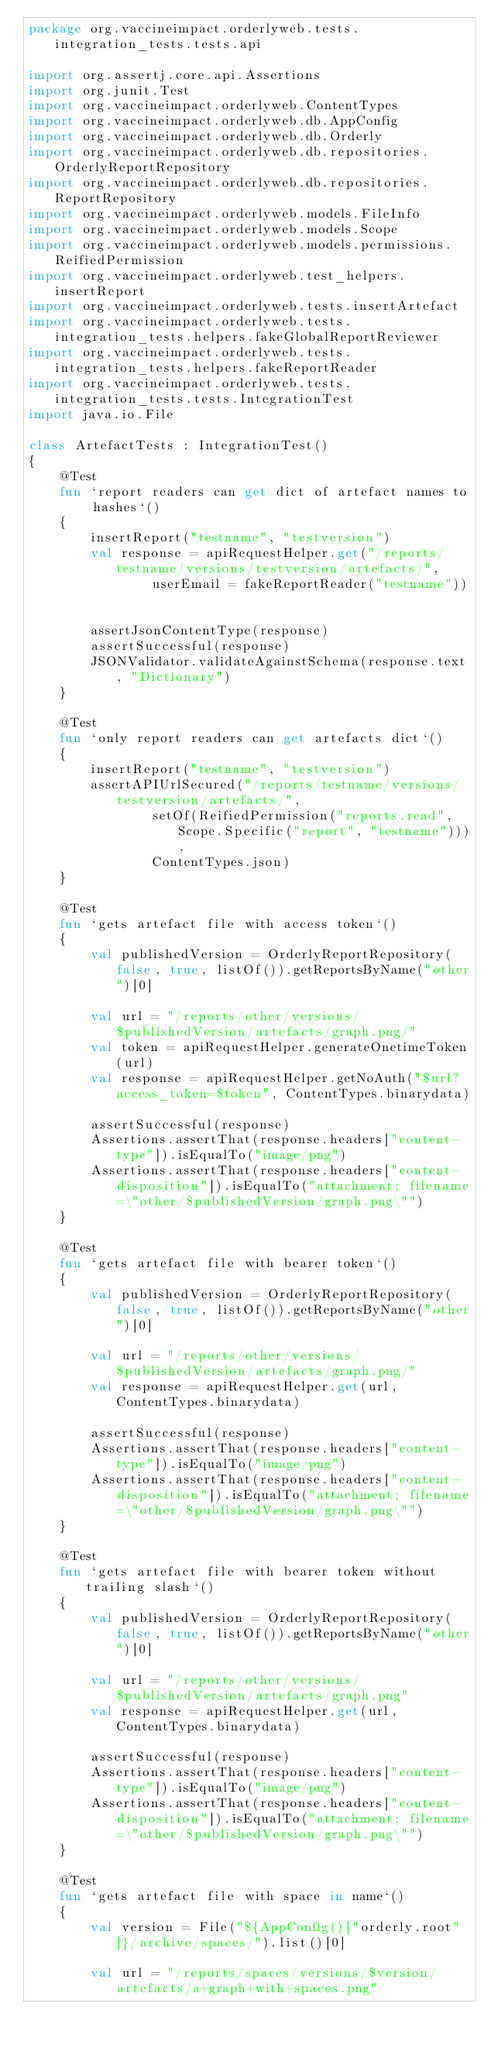<code> <loc_0><loc_0><loc_500><loc_500><_Kotlin_>package org.vaccineimpact.orderlyweb.tests.integration_tests.tests.api

import org.assertj.core.api.Assertions
import org.junit.Test
import org.vaccineimpact.orderlyweb.ContentTypes
import org.vaccineimpact.orderlyweb.db.AppConfig
import org.vaccineimpact.orderlyweb.db.Orderly
import org.vaccineimpact.orderlyweb.db.repositories.OrderlyReportRepository
import org.vaccineimpact.orderlyweb.db.repositories.ReportRepository
import org.vaccineimpact.orderlyweb.models.FileInfo
import org.vaccineimpact.orderlyweb.models.Scope
import org.vaccineimpact.orderlyweb.models.permissions.ReifiedPermission
import org.vaccineimpact.orderlyweb.test_helpers.insertReport
import org.vaccineimpact.orderlyweb.tests.insertArtefact
import org.vaccineimpact.orderlyweb.tests.integration_tests.helpers.fakeGlobalReportReviewer
import org.vaccineimpact.orderlyweb.tests.integration_tests.helpers.fakeReportReader
import org.vaccineimpact.orderlyweb.tests.integration_tests.tests.IntegrationTest
import java.io.File

class ArtefactTests : IntegrationTest()
{
    @Test
    fun `report readers can get dict of artefact names to hashes`()
    {
        insertReport("testname", "testversion")
        val response = apiRequestHelper.get("/reports/testname/versions/testversion/artefacts/",
                userEmail = fakeReportReader("testname"))


        assertJsonContentType(response)
        assertSuccessful(response)
        JSONValidator.validateAgainstSchema(response.text, "Dictionary")
    }

    @Test
    fun `only report readers can get artefacts dict`()
    {
        insertReport("testname", "testversion")
        assertAPIUrlSecured("/reports/testname/versions/testversion/artefacts/",
                setOf(ReifiedPermission("reports.read", Scope.Specific("report", "testname"))),
                ContentTypes.json)
    }

    @Test
    fun `gets artefact file with access token`()
    {
        val publishedVersion = OrderlyReportRepository(false, true, listOf()).getReportsByName("other")[0]

        val url = "/reports/other/versions/$publishedVersion/artefacts/graph.png/"
        val token = apiRequestHelper.generateOnetimeToken(url)
        val response = apiRequestHelper.getNoAuth("$url?access_token=$token", ContentTypes.binarydata)

        assertSuccessful(response)
        Assertions.assertThat(response.headers["content-type"]).isEqualTo("image/png")
        Assertions.assertThat(response.headers["content-disposition"]).isEqualTo("attachment; filename=\"other/$publishedVersion/graph.png\"")
    }

    @Test
    fun `gets artefact file with bearer token`()
    {
        val publishedVersion = OrderlyReportRepository(false, true, listOf()).getReportsByName("other")[0]

        val url = "/reports/other/versions/$publishedVersion/artefacts/graph.png/"
        val response = apiRequestHelper.get(url, ContentTypes.binarydata)

        assertSuccessful(response)
        Assertions.assertThat(response.headers["content-type"]).isEqualTo("image/png")
        Assertions.assertThat(response.headers["content-disposition"]).isEqualTo("attachment; filename=\"other/$publishedVersion/graph.png\"")
    }

    @Test
    fun `gets artefact file with bearer token without trailing slash`()
    {
        val publishedVersion = OrderlyReportRepository(false, true, listOf()).getReportsByName("other")[0]

        val url = "/reports/other/versions/$publishedVersion/artefacts/graph.png"
        val response = apiRequestHelper.get(url, ContentTypes.binarydata)

        assertSuccessful(response)
        Assertions.assertThat(response.headers["content-type"]).isEqualTo("image/png")
        Assertions.assertThat(response.headers["content-disposition"]).isEqualTo("attachment; filename=\"other/$publishedVersion/graph.png\"")
    }

    @Test
    fun `gets artefact file with space in name`()
    {
        val version = File("${AppConfig()["orderly.root"]}/archive/spaces/").list()[0]

        val url = "/reports/spaces/versions/$version/artefacts/a+graph+with+spaces.png"</code> 